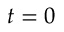Convert formula to latex. <formula><loc_0><loc_0><loc_500><loc_500>t = 0</formula> 